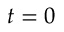Convert formula to latex. <formula><loc_0><loc_0><loc_500><loc_500>t = 0</formula> 